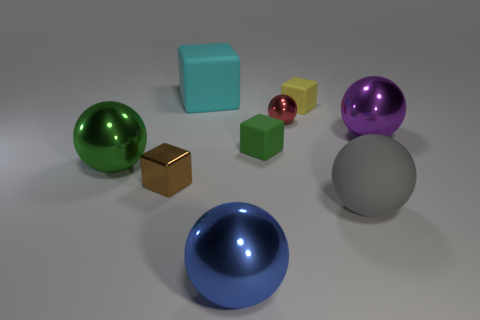Subtract all red spheres. How many spheres are left? 4 Add 1 green objects. How many objects exist? 10 Subtract 1 balls. How many balls are left? 4 Subtract all yellow cubes. How many cubes are left? 3 Subtract all blocks. How many objects are left? 5 Subtract all purple spheres. How many green blocks are left? 1 Subtract all cubes. Subtract all large green spheres. How many objects are left? 4 Add 2 red metal balls. How many red metal balls are left? 3 Add 2 big yellow metallic cylinders. How many big yellow metallic cylinders exist? 2 Subtract 0 red blocks. How many objects are left? 9 